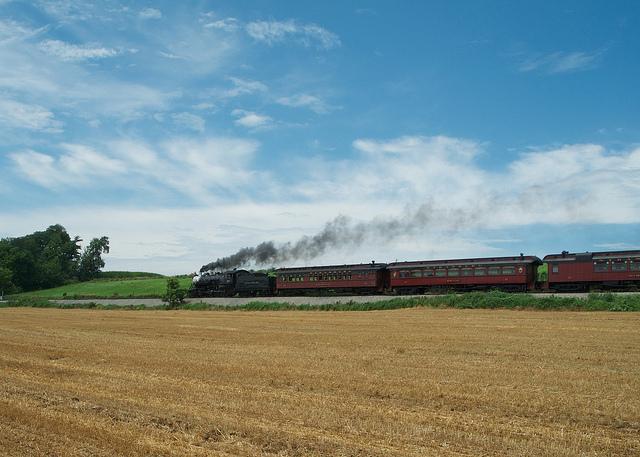What runs parallel to the tracks?
Concise answer only. Train. What area is this?
Keep it brief. Field. How many cars are attached to the train?
Write a very short answer. 3. How many compartments?
Quick response, please. 3. Is the ground flat?
Quick response, please. Yes. Is this an airplane?
Short answer required. No. What color is the grass?
Write a very short answer. Brown. 